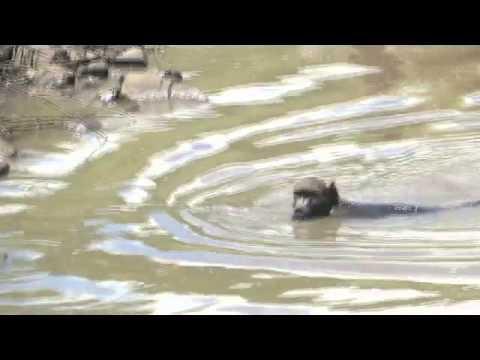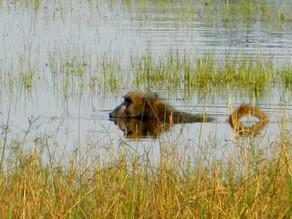The first image is the image on the left, the second image is the image on the right. Evaluate the accuracy of this statement regarding the images: "In one of the images, the pool is clearly man-made.". Is it true? Answer yes or no. No. The first image is the image on the left, the second image is the image on the right. For the images shown, is this caption "There is a man-made swimming area with a square corner." true? Answer yes or no. No. 